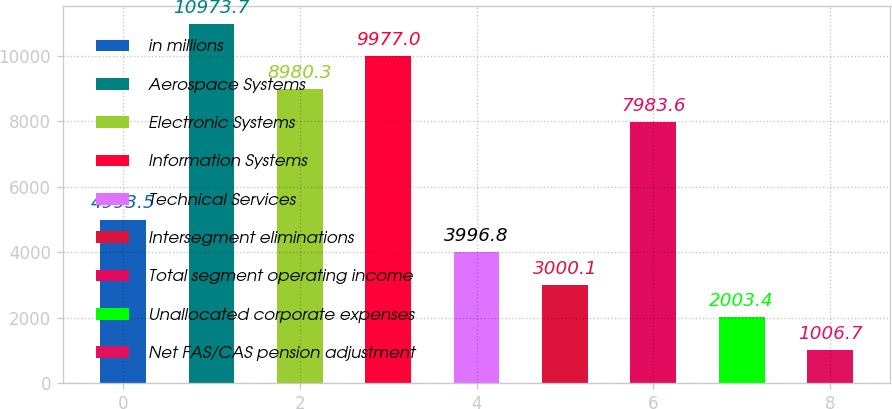<chart> <loc_0><loc_0><loc_500><loc_500><bar_chart><fcel>in millions<fcel>Aerospace Systems<fcel>Electronic Systems<fcel>Information Systems<fcel>Technical Services<fcel>Intersegment eliminations<fcel>Total segment operating income<fcel>Unallocated corporate expenses<fcel>Net FAS/CAS pension adjustment<nl><fcel>4993.5<fcel>10973.7<fcel>8980.3<fcel>9977<fcel>3996.8<fcel>3000.1<fcel>7983.6<fcel>2003.4<fcel>1006.7<nl></chart> 